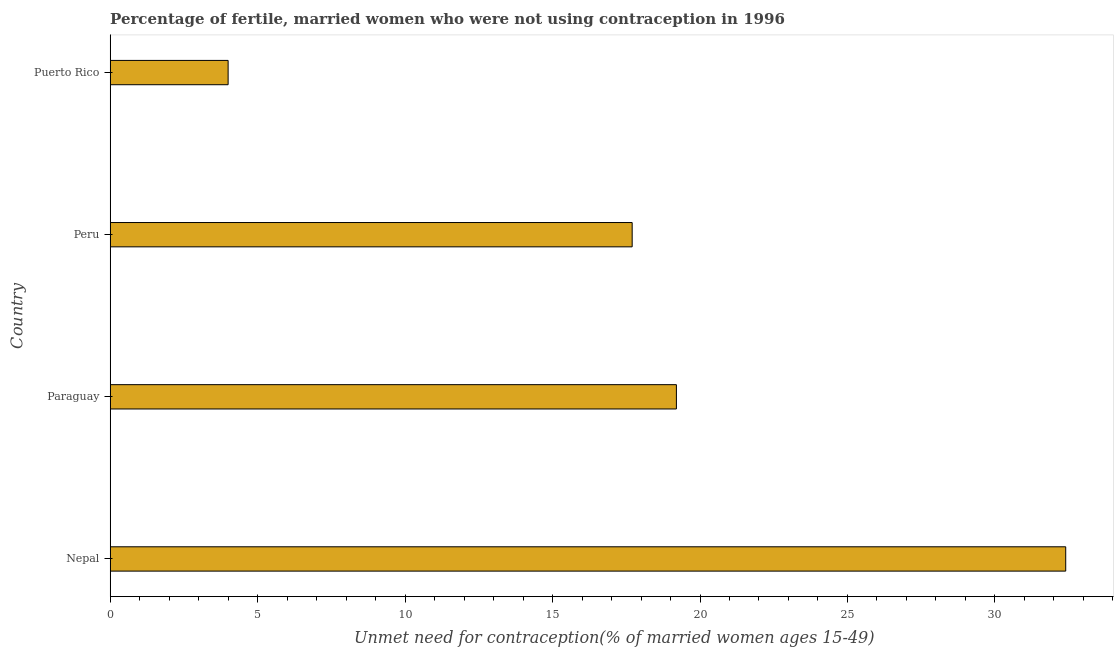Does the graph contain any zero values?
Offer a terse response. No. What is the title of the graph?
Your answer should be compact. Percentage of fertile, married women who were not using contraception in 1996. What is the label or title of the X-axis?
Give a very brief answer.  Unmet need for contraception(% of married women ages 15-49). What is the label or title of the Y-axis?
Offer a terse response. Country. What is the number of married women who are not using contraception in Paraguay?
Offer a terse response. 19.2. Across all countries, what is the maximum number of married women who are not using contraception?
Ensure brevity in your answer.  32.4. In which country was the number of married women who are not using contraception maximum?
Offer a very short reply. Nepal. In which country was the number of married women who are not using contraception minimum?
Make the answer very short. Puerto Rico. What is the sum of the number of married women who are not using contraception?
Provide a short and direct response. 73.3. What is the difference between the number of married women who are not using contraception in Nepal and Paraguay?
Your answer should be very brief. 13.2. What is the average number of married women who are not using contraception per country?
Your answer should be compact. 18.32. What is the median number of married women who are not using contraception?
Make the answer very short. 18.45. What is the ratio of the number of married women who are not using contraception in Nepal to that in Peru?
Offer a very short reply. 1.83. Is the number of married women who are not using contraception in Paraguay less than that in Puerto Rico?
Make the answer very short. No. What is the difference between the highest and the lowest number of married women who are not using contraception?
Provide a succinct answer. 28.4. How many bars are there?
Your answer should be compact. 4. Are all the bars in the graph horizontal?
Ensure brevity in your answer.  Yes. Are the values on the major ticks of X-axis written in scientific E-notation?
Provide a short and direct response. No. What is the  Unmet need for contraception(% of married women ages 15-49) of Nepal?
Give a very brief answer. 32.4. What is the  Unmet need for contraception(% of married women ages 15-49) of Peru?
Provide a short and direct response. 17.7. What is the difference between the  Unmet need for contraception(% of married women ages 15-49) in Nepal and Puerto Rico?
Keep it short and to the point. 28.4. What is the difference between the  Unmet need for contraception(% of married women ages 15-49) in Paraguay and Peru?
Offer a very short reply. 1.5. What is the difference between the  Unmet need for contraception(% of married women ages 15-49) in Peru and Puerto Rico?
Offer a very short reply. 13.7. What is the ratio of the  Unmet need for contraception(% of married women ages 15-49) in Nepal to that in Paraguay?
Your response must be concise. 1.69. What is the ratio of the  Unmet need for contraception(% of married women ages 15-49) in Nepal to that in Peru?
Keep it short and to the point. 1.83. What is the ratio of the  Unmet need for contraception(% of married women ages 15-49) in Nepal to that in Puerto Rico?
Provide a succinct answer. 8.1. What is the ratio of the  Unmet need for contraception(% of married women ages 15-49) in Paraguay to that in Peru?
Your response must be concise. 1.08. What is the ratio of the  Unmet need for contraception(% of married women ages 15-49) in Peru to that in Puerto Rico?
Offer a terse response. 4.42. 